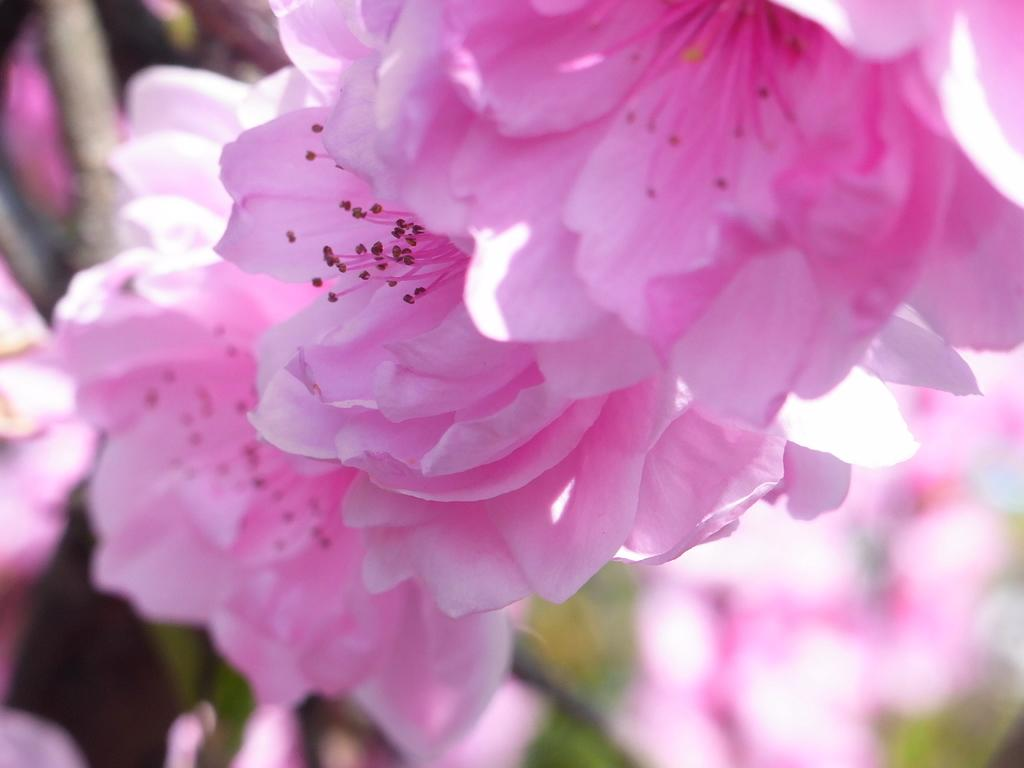What color are the flowers in the image? The flowers in the image are pink. What type of vegetation is present in the image? There are plants in the image. Can you describe the setting where the image might have been taken? The image may have been taken in a garden. What type of cake is being served by the police officer in the image? There is no police officer or cake present in the image. 